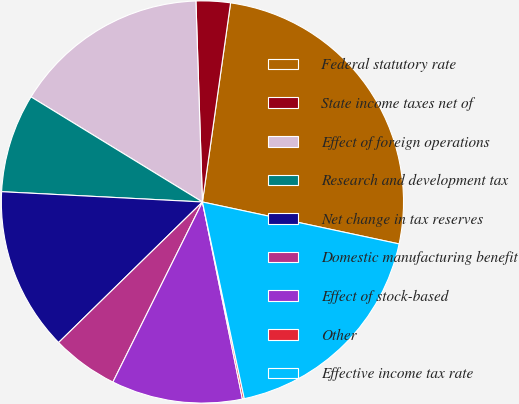Convert chart. <chart><loc_0><loc_0><loc_500><loc_500><pie_chart><fcel>Federal statutory rate<fcel>State income taxes net of<fcel>Effect of foreign operations<fcel>Research and development tax<fcel>Net change in tax reserves<fcel>Domestic manufacturing benefit<fcel>Effect of stock-based<fcel>Other<fcel>Effective income tax rate<nl><fcel>26.11%<fcel>2.75%<fcel>15.73%<fcel>7.94%<fcel>13.13%<fcel>5.34%<fcel>10.53%<fcel>0.15%<fcel>18.32%<nl></chart> 